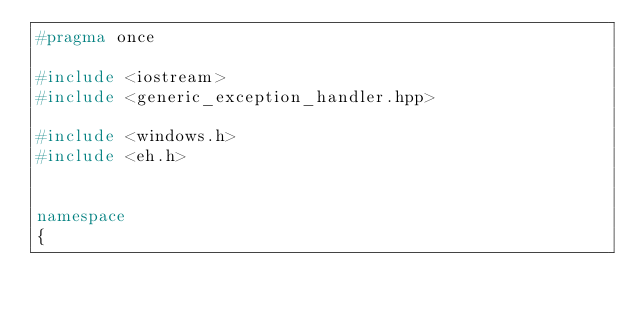<code> <loc_0><loc_0><loc_500><loc_500><_C++_>#pragma once

#include <iostream>
#include <generic_exception_handler.hpp>

#include <windows.h>
#include <eh.h>


namespace
{</code> 